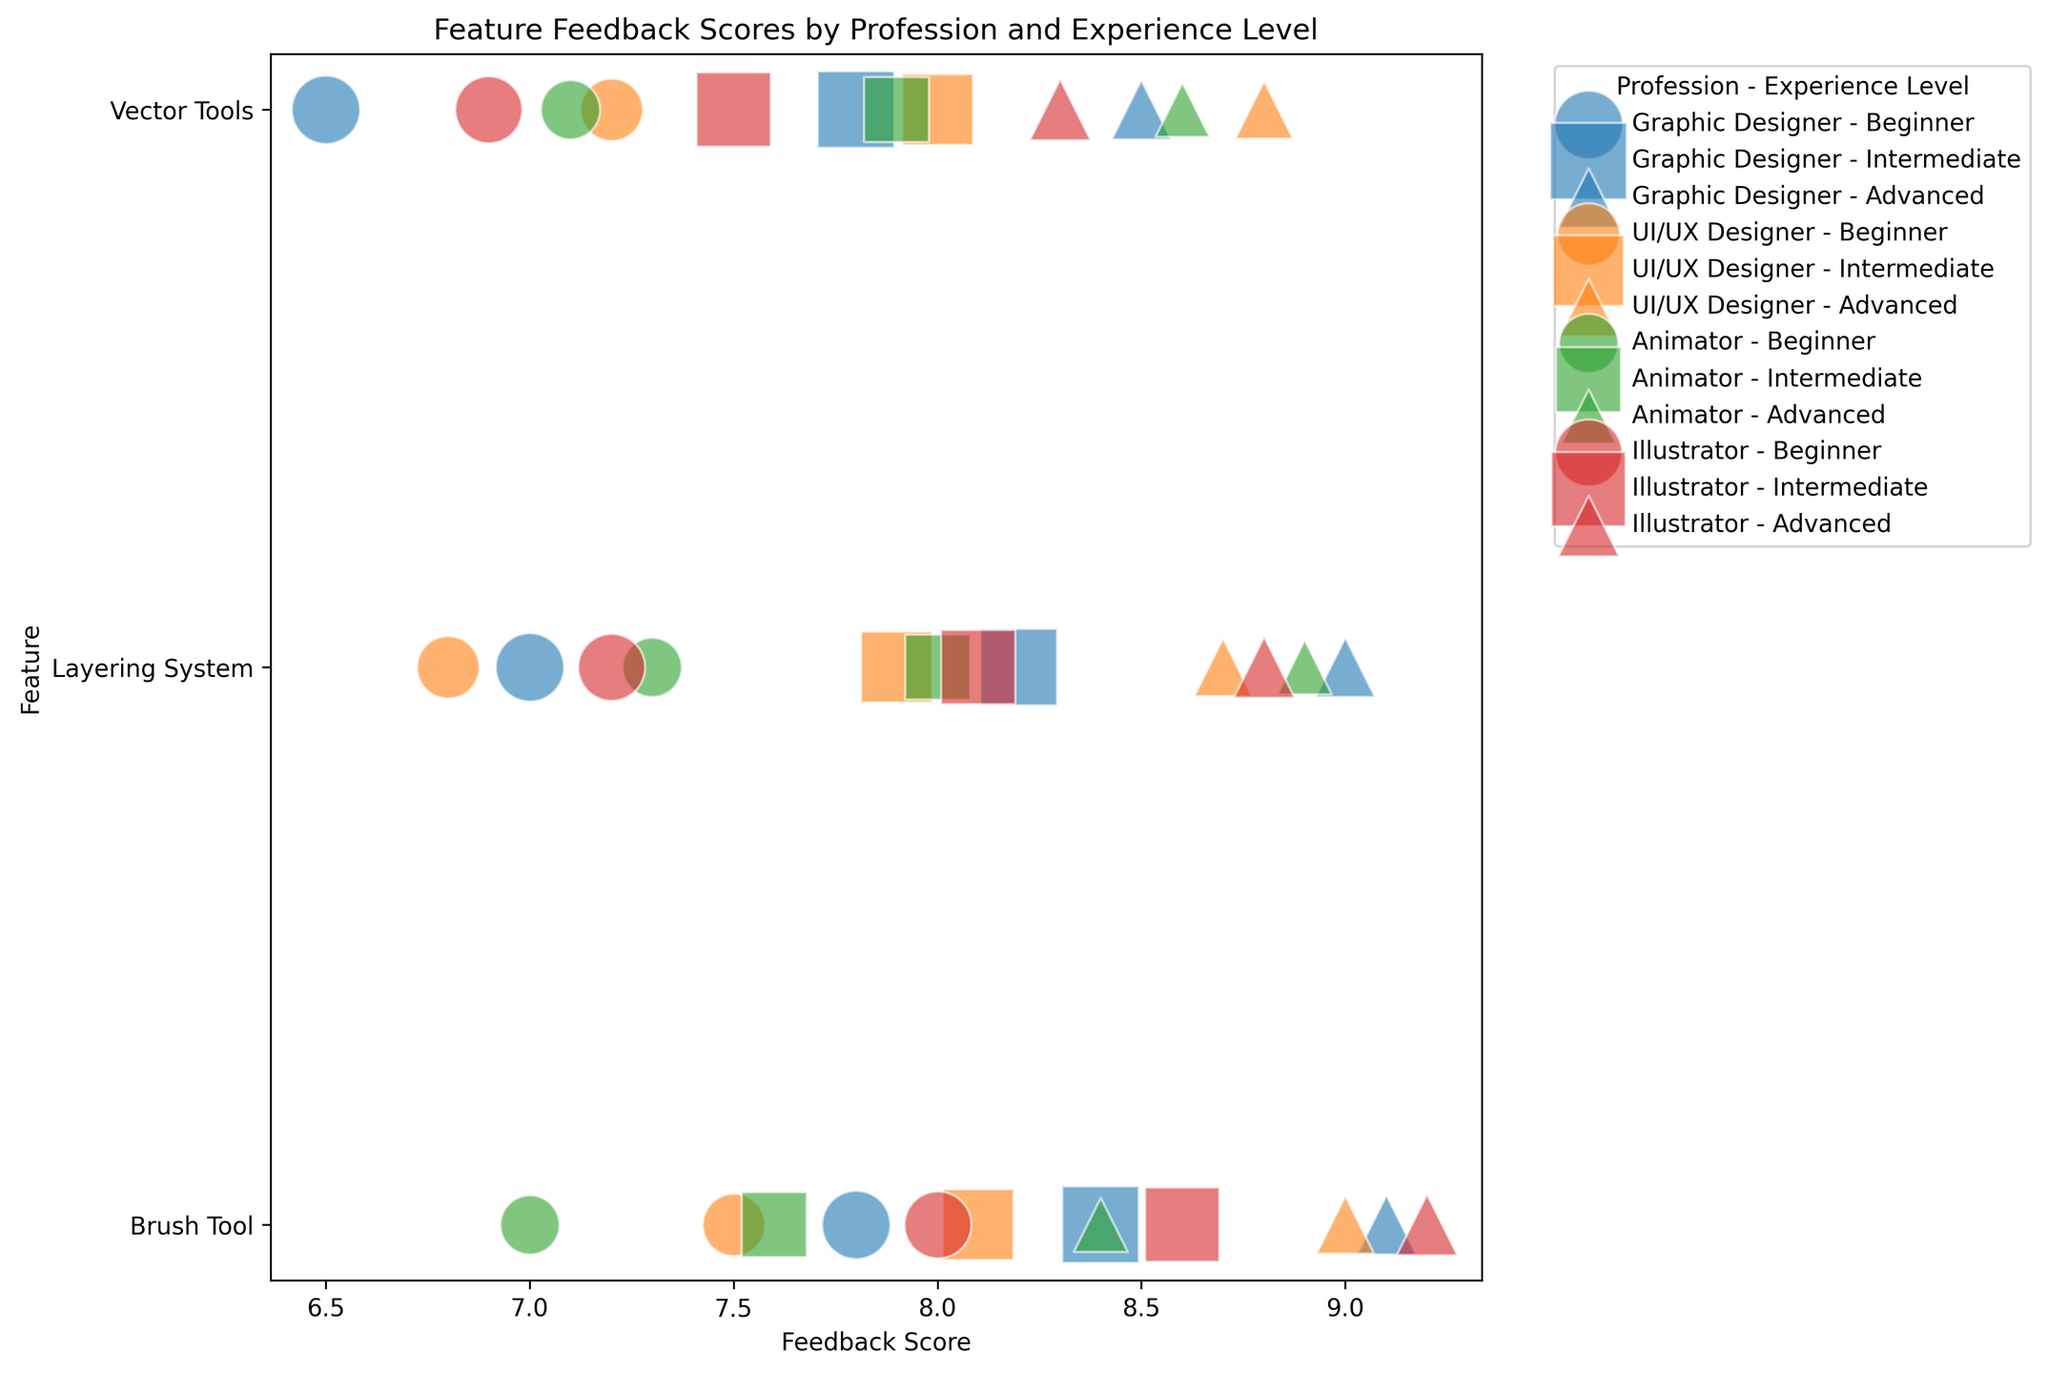Which feature has the highest feedback score for Intermediate UI/UX Designers? First, locate all the bubbles representing Intermediate UI/UX Designers. Then find the bubble with the highest Feedback Score among those; it is for the Vector Tools feature.
Answer: Vector Tools How does the feedback score for the Brush Tool differ between Beginner and Advanced Animators? First, locate the feedback scores for Beginner Animators (7.0) and Advanced Animators (8.4) for the Brush Tool. Calculate the difference: 8.4 - 7.0 = 1.4.
Answer: 1.4 Which profession has the smallest number of users providing feedback on the Layering System as Beginners? Identify the bubbles representing Beginners for the Layering System across professions and look for the smallest size. It corresponds to the Animator profession.
Answer: Animator What is the average feedback score for the Vector Tools feature across all Advanced users? Locate the feedback scores for Advanced users of the Vector Tools feature: 8.5 (Graphic Designer), 8.8 (UI/UX Designer), 8.6 (Animator), and 8.3 (Illustrator). Calculate the average: (8.5 + 8.8 + 8.6 + 8.3) / 4 = 8.55.
Answer: 8.55 Which experience level of Illustrators provided the highest feedback score for the Brush Tool? Identify the feedback scores for Beginner, Intermediate, and Advanced Illustrators for the Brush Tool. The Advanced group provided the highest score of 9.2.
Answer: Advanced Between UI/UX Designers and Animators, which profession gives a higher average feedback score for the Layering System at the Intermediate level? Locate the feedback scores for Intermediate users of the Layering System: 7.9 (UI/UX Designer) and 8.0 (Animator). Compare the two values: 8.0 is higher than 7.9.
Answer: Animator What is the total number of users who provided feedback on the Brush Tool for Intermediate users across all professions? Sum the number of users for Intermediate users for each profession: 150 (Graphic Designer), 130 (UI/UX Designer), 110 (Animator), 140 (Illustrator). The total is 530.
Answer: 530 Compare the feedback scores for the Layering System between Beginner Graphic Designers and Beginner Illustrators. Which is higher? Identify the feedback scores for Beginner Graphic Designers and Illustrators for the Layering System: 7.0 and 7.2 respectively. 7.2 is higher.
Answer: Beginner Illustrators What is the difference between the highest and lowest feedback scores for Advanced users of the Brush Tool for any profession? Identify the highest and lowest feedback scores for Advanced users of the Brush Tool: 9.2 (Illustrator) and 8.4 (Animator). Calculate the difference: 9.2 - 8.4 = 0.8.
Answer: 0.8 